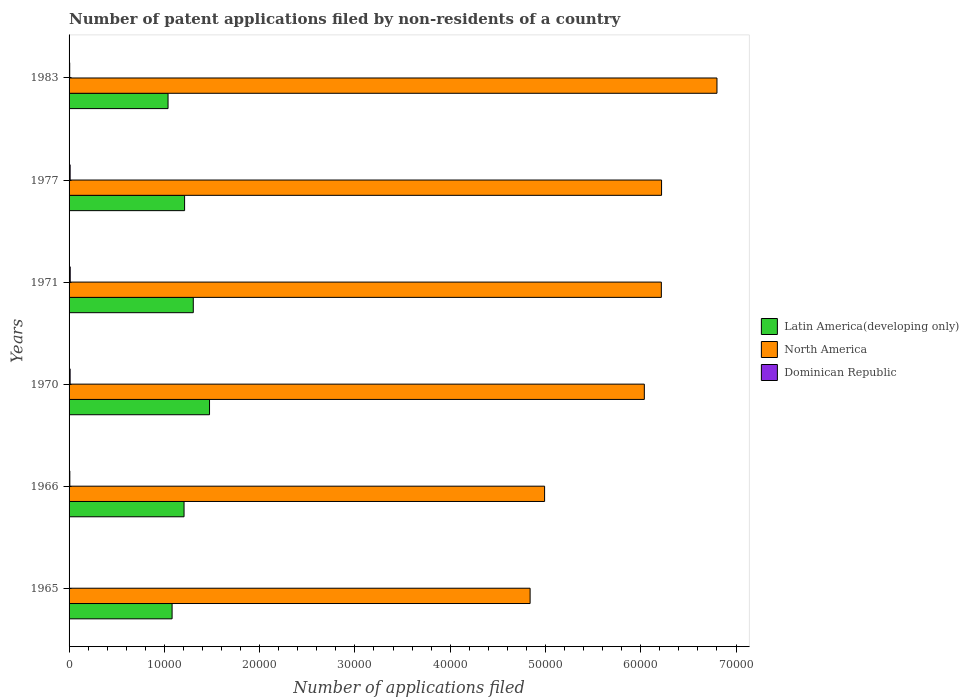How many bars are there on the 2nd tick from the bottom?
Give a very brief answer. 3. What is the number of applications filed in Latin America(developing only) in 1966?
Give a very brief answer. 1.21e+04. Across all years, what is the maximum number of applications filed in Dominican Republic?
Your response must be concise. 120. Across all years, what is the minimum number of applications filed in Latin America(developing only)?
Your answer should be very brief. 1.04e+04. In which year was the number of applications filed in Latin America(developing only) maximum?
Keep it short and to the point. 1970. In which year was the number of applications filed in North America minimum?
Your answer should be very brief. 1965. What is the total number of applications filed in Dominican Republic in the graph?
Your answer should be compact. 503. What is the difference between the number of applications filed in Latin America(developing only) in 1965 and that in 1970?
Your answer should be very brief. -3930. What is the difference between the number of applications filed in North America in 1970 and the number of applications filed in Dominican Republic in 1983?
Your answer should be very brief. 6.03e+04. What is the average number of applications filed in Dominican Republic per year?
Provide a succinct answer. 83.83. In the year 1970, what is the difference between the number of applications filed in Latin America(developing only) and number of applications filed in Dominican Republic?
Your answer should be compact. 1.46e+04. What is the ratio of the number of applications filed in North America in 1970 to that in 1983?
Provide a short and direct response. 0.89. What is the difference between the highest and the second highest number of applications filed in Latin America(developing only)?
Provide a short and direct response. 1706. What is the difference between the highest and the lowest number of applications filed in North America?
Provide a short and direct response. 1.96e+04. In how many years, is the number of applications filed in North America greater than the average number of applications filed in North America taken over all years?
Make the answer very short. 4. What does the 3rd bar from the top in 1977 represents?
Provide a short and direct response. Latin America(developing only). What does the 3rd bar from the bottom in 1966 represents?
Your response must be concise. Dominican Republic. Is it the case that in every year, the sum of the number of applications filed in Dominican Republic and number of applications filed in North America is greater than the number of applications filed in Latin America(developing only)?
Keep it short and to the point. Yes. How many bars are there?
Make the answer very short. 18. Are all the bars in the graph horizontal?
Offer a terse response. Yes. How many years are there in the graph?
Make the answer very short. 6. What is the difference between two consecutive major ticks on the X-axis?
Make the answer very short. 10000. Does the graph contain grids?
Give a very brief answer. No. How many legend labels are there?
Your answer should be very brief. 3. How are the legend labels stacked?
Your answer should be very brief. Vertical. What is the title of the graph?
Provide a short and direct response. Number of patent applications filed by non-residents of a country. What is the label or title of the X-axis?
Provide a succinct answer. Number of applications filed. What is the Number of applications filed in Latin America(developing only) in 1965?
Offer a terse response. 1.08e+04. What is the Number of applications filed of North America in 1965?
Give a very brief answer. 4.84e+04. What is the Number of applications filed in Dominican Republic in 1965?
Offer a very short reply. 15. What is the Number of applications filed in Latin America(developing only) in 1966?
Provide a short and direct response. 1.21e+04. What is the Number of applications filed in North America in 1966?
Offer a terse response. 4.99e+04. What is the Number of applications filed of Dominican Republic in 1966?
Provide a short and direct response. 80. What is the Number of applications filed of Latin America(developing only) in 1970?
Your response must be concise. 1.47e+04. What is the Number of applications filed in North America in 1970?
Ensure brevity in your answer.  6.04e+04. What is the Number of applications filed in Dominican Republic in 1970?
Provide a succinct answer. 110. What is the Number of applications filed of Latin America(developing only) in 1971?
Your answer should be very brief. 1.30e+04. What is the Number of applications filed of North America in 1971?
Ensure brevity in your answer.  6.22e+04. What is the Number of applications filed in Dominican Republic in 1971?
Give a very brief answer. 120. What is the Number of applications filed of Latin America(developing only) in 1977?
Your answer should be compact. 1.21e+04. What is the Number of applications filed of North America in 1977?
Make the answer very short. 6.22e+04. What is the Number of applications filed of Dominican Republic in 1977?
Make the answer very short. 112. What is the Number of applications filed of Latin America(developing only) in 1983?
Your answer should be compact. 1.04e+04. What is the Number of applications filed of North America in 1983?
Offer a very short reply. 6.80e+04. What is the Number of applications filed of Dominican Republic in 1983?
Make the answer very short. 66. Across all years, what is the maximum Number of applications filed of Latin America(developing only)?
Offer a terse response. 1.47e+04. Across all years, what is the maximum Number of applications filed of North America?
Your answer should be compact. 6.80e+04. Across all years, what is the maximum Number of applications filed in Dominican Republic?
Offer a very short reply. 120. Across all years, what is the minimum Number of applications filed in Latin America(developing only)?
Your response must be concise. 1.04e+04. Across all years, what is the minimum Number of applications filed of North America?
Provide a succinct answer. 4.84e+04. Across all years, what is the minimum Number of applications filed in Dominican Republic?
Ensure brevity in your answer.  15. What is the total Number of applications filed of Latin America(developing only) in the graph?
Your answer should be very brief. 7.32e+04. What is the total Number of applications filed of North America in the graph?
Your answer should be compact. 3.51e+05. What is the total Number of applications filed of Dominican Republic in the graph?
Your answer should be very brief. 503. What is the difference between the Number of applications filed of Latin America(developing only) in 1965 and that in 1966?
Offer a very short reply. -1254. What is the difference between the Number of applications filed of North America in 1965 and that in 1966?
Offer a very short reply. -1520. What is the difference between the Number of applications filed of Dominican Republic in 1965 and that in 1966?
Provide a short and direct response. -65. What is the difference between the Number of applications filed in Latin America(developing only) in 1965 and that in 1970?
Make the answer very short. -3930. What is the difference between the Number of applications filed of North America in 1965 and that in 1970?
Your answer should be very brief. -1.20e+04. What is the difference between the Number of applications filed of Dominican Republic in 1965 and that in 1970?
Your answer should be compact. -95. What is the difference between the Number of applications filed in Latin America(developing only) in 1965 and that in 1971?
Give a very brief answer. -2224. What is the difference between the Number of applications filed in North America in 1965 and that in 1971?
Offer a terse response. -1.38e+04. What is the difference between the Number of applications filed of Dominican Republic in 1965 and that in 1971?
Make the answer very short. -105. What is the difference between the Number of applications filed in Latin America(developing only) in 1965 and that in 1977?
Give a very brief answer. -1312. What is the difference between the Number of applications filed in North America in 1965 and that in 1977?
Offer a very short reply. -1.38e+04. What is the difference between the Number of applications filed of Dominican Republic in 1965 and that in 1977?
Give a very brief answer. -97. What is the difference between the Number of applications filed of Latin America(developing only) in 1965 and that in 1983?
Make the answer very short. 425. What is the difference between the Number of applications filed of North America in 1965 and that in 1983?
Provide a short and direct response. -1.96e+04. What is the difference between the Number of applications filed of Dominican Republic in 1965 and that in 1983?
Make the answer very short. -51. What is the difference between the Number of applications filed of Latin America(developing only) in 1966 and that in 1970?
Provide a succinct answer. -2676. What is the difference between the Number of applications filed of North America in 1966 and that in 1970?
Make the answer very short. -1.05e+04. What is the difference between the Number of applications filed in Latin America(developing only) in 1966 and that in 1971?
Provide a short and direct response. -970. What is the difference between the Number of applications filed in North America in 1966 and that in 1971?
Provide a short and direct response. -1.23e+04. What is the difference between the Number of applications filed of Latin America(developing only) in 1966 and that in 1977?
Provide a succinct answer. -58. What is the difference between the Number of applications filed of North America in 1966 and that in 1977?
Provide a succinct answer. -1.23e+04. What is the difference between the Number of applications filed of Dominican Republic in 1966 and that in 1977?
Your answer should be compact. -32. What is the difference between the Number of applications filed in Latin America(developing only) in 1966 and that in 1983?
Ensure brevity in your answer.  1679. What is the difference between the Number of applications filed of North America in 1966 and that in 1983?
Your response must be concise. -1.81e+04. What is the difference between the Number of applications filed in Latin America(developing only) in 1970 and that in 1971?
Provide a succinct answer. 1706. What is the difference between the Number of applications filed in North America in 1970 and that in 1971?
Offer a very short reply. -1786. What is the difference between the Number of applications filed of Dominican Republic in 1970 and that in 1971?
Offer a terse response. -10. What is the difference between the Number of applications filed of Latin America(developing only) in 1970 and that in 1977?
Your response must be concise. 2618. What is the difference between the Number of applications filed in North America in 1970 and that in 1977?
Give a very brief answer. -1808. What is the difference between the Number of applications filed of Latin America(developing only) in 1970 and that in 1983?
Ensure brevity in your answer.  4355. What is the difference between the Number of applications filed of North America in 1970 and that in 1983?
Ensure brevity in your answer.  -7624. What is the difference between the Number of applications filed in Latin America(developing only) in 1971 and that in 1977?
Your answer should be very brief. 912. What is the difference between the Number of applications filed in North America in 1971 and that in 1977?
Make the answer very short. -22. What is the difference between the Number of applications filed in Dominican Republic in 1971 and that in 1977?
Give a very brief answer. 8. What is the difference between the Number of applications filed of Latin America(developing only) in 1971 and that in 1983?
Provide a succinct answer. 2649. What is the difference between the Number of applications filed in North America in 1971 and that in 1983?
Offer a very short reply. -5838. What is the difference between the Number of applications filed in Latin America(developing only) in 1977 and that in 1983?
Offer a very short reply. 1737. What is the difference between the Number of applications filed in North America in 1977 and that in 1983?
Ensure brevity in your answer.  -5816. What is the difference between the Number of applications filed of Dominican Republic in 1977 and that in 1983?
Provide a short and direct response. 46. What is the difference between the Number of applications filed in Latin America(developing only) in 1965 and the Number of applications filed in North America in 1966?
Provide a short and direct response. -3.91e+04. What is the difference between the Number of applications filed of Latin America(developing only) in 1965 and the Number of applications filed of Dominican Republic in 1966?
Make the answer very short. 1.07e+04. What is the difference between the Number of applications filed of North America in 1965 and the Number of applications filed of Dominican Republic in 1966?
Your answer should be very brief. 4.83e+04. What is the difference between the Number of applications filed in Latin America(developing only) in 1965 and the Number of applications filed in North America in 1970?
Your answer should be compact. -4.96e+04. What is the difference between the Number of applications filed of Latin America(developing only) in 1965 and the Number of applications filed of Dominican Republic in 1970?
Provide a short and direct response. 1.07e+04. What is the difference between the Number of applications filed of North America in 1965 and the Number of applications filed of Dominican Republic in 1970?
Offer a terse response. 4.83e+04. What is the difference between the Number of applications filed in Latin America(developing only) in 1965 and the Number of applications filed in North America in 1971?
Your answer should be compact. -5.14e+04. What is the difference between the Number of applications filed in Latin America(developing only) in 1965 and the Number of applications filed in Dominican Republic in 1971?
Your response must be concise. 1.07e+04. What is the difference between the Number of applications filed of North America in 1965 and the Number of applications filed of Dominican Republic in 1971?
Give a very brief answer. 4.83e+04. What is the difference between the Number of applications filed of Latin America(developing only) in 1965 and the Number of applications filed of North America in 1977?
Make the answer very short. -5.14e+04. What is the difference between the Number of applications filed in Latin America(developing only) in 1965 and the Number of applications filed in Dominican Republic in 1977?
Your response must be concise. 1.07e+04. What is the difference between the Number of applications filed in North America in 1965 and the Number of applications filed in Dominican Republic in 1977?
Make the answer very short. 4.83e+04. What is the difference between the Number of applications filed of Latin America(developing only) in 1965 and the Number of applications filed of North America in 1983?
Give a very brief answer. -5.72e+04. What is the difference between the Number of applications filed in Latin America(developing only) in 1965 and the Number of applications filed in Dominican Republic in 1983?
Give a very brief answer. 1.07e+04. What is the difference between the Number of applications filed in North America in 1965 and the Number of applications filed in Dominican Republic in 1983?
Offer a very short reply. 4.83e+04. What is the difference between the Number of applications filed of Latin America(developing only) in 1966 and the Number of applications filed of North America in 1970?
Your answer should be very brief. -4.83e+04. What is the difference between the Number of applications filed in Latin America(developing only) in 1966 and the Number of applications filed in Dominican Republic in 1970?
Provide a succinct answer. 1.20e+04. What is the difference between the Number of applications filed in North America in 1966 and the Number of applications filed in Dominican Republic in 1970?
Ensure brevity in your answer.  4.98e+04. What is the difference between the Number of applications filed in Latin America(developing only) in 1966 and the Number of applications filed in North America in 1971?
Keep it short and to the point. -5.01e+04. What is the difference between the Number of applications filed in Latin America(developing only) in 1966 and the Number of applications filed in Dominican Republic in 1971?
Your answer should be very brief. 1.19e+04. What is the difference between the Number of applications filed in North America in 1966 and the Number of applications filed in Dominican Republic in 1971?
Offer a terse response. 4.98e+04. What is the difference between the Number of applications filed of Latin America(developing only) in 1966 and the Number of applications filed of North America in 1977?
Provide a short and direct response. -5.01e+04. What is the difference between the Number of applications filed of Latin America(developing only) in 1966 and the Number of applications filed of Dominican Republic in 1977?
Keep it short and to the point. 1.20e+04. What is the difference between the Number of applications filed of North America in 1966 and the Number of applications filed of Dominican Republic in 1977?
Make the answer very short. 4.98e+04. What is the difference between the Number of applications filed in Latin America(developing only) in 1966 and the Number of applications filed in North America in 1983?
Offer a very short reply. -5.59e+04. What is the difference between the Number of applications filed of Latin America(developing only) in 1966 and the Number of applications filed of Dominican Republic in 1983?
Ensure brevity in your answer.  1.20e+04. What is the difference between the Number of applications filed of North America in 1966 and the Number of applications filed of Dominican Republic in 1983?
Your response must be concise. 4.98e+04. What is the difference between the Number of applications filed of Latin America(developing only) in 1970 and the Number of applications filed of North America in 1971?
Give a very brief answer. -4.74e+04. What is the difference between the Number of applications filed of Latin America(developing only) in 1970 and the Number of applications filed of Dominican Republic in 1971?
Give a very brief answer. 1.46e+04. What is the difference between the Number of applications filed in North America in 1970 and the Number of applications filed in Dominican Republic in 1971?
Ensure brevity in your answer.  6.03e+04. What is the difference between the Number of applications filed of Latin America(developing only) in 1970 and the Number of applications filed of North America in 1977?
Ensure brevity in your answer.  -4.74e+04. What is the difference between the Number of applications filed in Latin America(developing only) in 1970 and the Number of applications filed in Dominican Republic in 1977?
Your response must be concise. 1.46e+04. What is the difference between the Number of applications filed in North America in 1970 and the Number of applications filed in Dominican Republic in 1977?
Offer a terse response. 6.03e+04. What is the difference between the Number of applications filed of Latin America(developing only) in 1970 and the Number of applications filed of North America in 1983?
Your answer should be compact. -5.33e+04. What is the difference between the Number of applications filed in Latin America(developing only) in 1970 and the Number of applications filed in Dominican Republic in 1983?
Make the answer very short. 1.47e+04. What is the difference between the Number of applications filed in North America in 1970 and the Number of applications filed in Dominican Republic in 1983?
Ensure brevity in your answer.  6.03e+04. What is the difference between the Number of applications filed of Latin America(developing only) in 1971 and the Number of applications filed of North America in 1977?
Your response must be concise. -4.91e+04. What is the difference between the Number of applications filed in Latin America(developing only) in 1971 and the Number of applications filed in Dominican Republic in 1977?
Give a very brief answer. 1.29e+04. What is the difference between the Number of applications filed in North America in 1971 and the Number of applications filed in Dominican Republic in 1977?
Offer a terse response. 6.21e+04. What is the difference between the Number of applications filed in Latin America(developing only) in 1971 and the Number of applications filed in North America in 1983?
Give a very brief answer. -5.50e+04. What is the difference between the Number of applications filed in Latin America(developing only) in 1971 and the Number of applications filed in Dominican Republic in 1983?
Your answer should be compact. 1.30e+04. What is the difference between the Number of applications filed in North America in 1971 and the Number of applications filed in Dominican Republic in 1983?
Ensure brevity in your answer.  6.21e+04. What is the difference between the Number of applications filed of Latin America(developing only) in 1977 and the Number of applications filed of North America in 1983?
Ensure brevity in your answer.  -5.59e+04. What is the difference between the Number of applications filed of Latin America(developing only) in 1977 and the Number of applications filed of Dominican Republic in 1983?
Offer a very short reply. 1.21e+04. What is the difference between the Number of applications filed of North America in 1977 and the Number of applications filed of Dominican Republic in 1983?
Keep it short and to the point. 6.21e+04. What is the average Number of applications filed of Latin America(developing only) per year?
Offer a terse response. 1.22e+04. What is the average Number of applications filed in North America per year?
Keep it short and to the point. 5.85e+04. What is the average Number of applications filed of Dominican Republic per year?
Provide a succinct answer. 83.83. In the year 1965, what is the difference between the Number of applications filed of Latin America(developing only) and Number of applications filed of North America?
Your answer should be compact. -3.76e+04. In the year 1965, what is the difference between the Number of applications filed of Latin America(developing only) and Number of applications filed of Dominican Republic?
Your answer should be very brief. 1.08e+04. In the year 1965, what is the difference between the Number of applications filed in North America and Number of applications filed in Dominican Republic?
Provide a short and direct response. 4.84e+04. In the year 1966, what is the difference between the Number of applications filed in Latin America(developing only) and Number of applications filed in North America?
Your answer should be very brief. -3.78e+04. In the year 1966, what is the difference between the Number of applications filed in Latin America(developing only) and Number of applications filed in Dominican Republic?
Provide a short and direct response. 1.20e+04. In the year 1966, what is the difference between the Number of applications filed of North America and Number of applications filed of Dominican Republic?
Provide a succinct answer. 4.98e+04. In the year 1970, what is the difference between the Number of applications filed of Latin America(developing only) and Number of applications filed of North America?
Give a very brief answer. -4.56e+04. In the year 1970, what is the difference between the Number of applications filed in Latin America(developing only) and Number of applications filed in Dominican Republic?
Make the answer very short. 1.46e+04. In the year 1970, what is the difference between the Number of applications filed of North America and Number of applications filed of Dominican Republic?
Offer a very short reply. 6.03e+04. In the year 1971, what is the difference between the Number of applications filed in Latin America(developing only) and Number of applications filed in North America?
Offer a terse response. -4.91e+04. In the year 1971, what is the difference between the Number of applications filed in Latin America(developing only) and Number of applications filed in Dominican Republic?
Give a very brief answer. 1.29e+04. In the year 1971, what is the difference between the Number of applications filed in North America and Number of applications filed in Dominican Republic?
Make the answer very short. 6.20e+04. In the year 1977, what is the difference between the Number of applications filed in Latin America(developing only) and Number of applications filed in North America?
Offer a terse response. -5.01e+04. In the year 1977, what is the difference between the Number of applications filed of Latin America(developing only) and Number of applications filed of Dominican Republic?
Make the answer very short. 1.20e+04. In the year 1977, what is the difference between the Number of applications filed of North America and Number of applications filed of Dominican Republic?
Offer a terse response. 6.21e+04. In the year 1983, what is the difference between the Number of applications filed of Latin America(developing only) and Number of applications filed of North America?
Your answer should be compact. -5.76e+04. In the year 1983, what is the difference between the Number of applications filed in Latin America(developing only) and Number of applications filed in Dominican Republic?
Give a very brief answer. 1.03e+04. In the year 1983, what is the difference between the Number of applications filed of North America and Number of applications filed of Dominican Republic?
Your answer should be compact. 6.79e+04. What is the ratio of the Number of applications filed of Latin America(developing only) in 1965 to that in 1966?
Provide a succinct answer. 0.9. What is the ratio of the Number of applications filed of North America in 1965 to that in 1966?
Keep it short and to the point. 0.97. What is the ratio of the Number of applications filed of Dominican Republic in 1965 to that in 1966?
Provide a short and direct response. 0.19. What is the ratio of the Number of applications filed in Latin America(developing only) in 1965 to that in 1970?
Offer a very short reply. 0.73. What is the ratio of the Number of applications filed in North America in 1965 to that in 1970?
Make the answer very short. 0.8. What is the ratio of the Number of applications filed of Dominican Republic in 1965 to that in 1970?
Offer a very short reply. 0.14. What is the ratio of the Number of applications filed of Latin America(developing only) in 1965 to that in 1971?
Offer a very short reply. 0.83. What is the ratio of the Number of applications filed in North America in 1965 to that in 1971?
Give a very brief answer. 0.78. What is the ratio of the Number of applications filed in Latin America(developing only) in 1965 to that in 1977?
Ensure brevity in your answer.  0.89. What is the ratio of the Number of applications filed of North America in 1965 to that in 1977?
Your answer should be compact. 0.78. What is the ratio of the Number of applications filed in Dominican Republic in 1965 to that in 1977?
Ensure brevity in your answer.  0.13. What is the ratio of the Number of applications filed of Latin America(developing only) in 1965 to that in 1983?
Your answer should be very brief. 1.04. What is the ratio of the Number of applications filed in North America in 1965 to that in 1983?
Your answer should be very brief. 0.71. What is the ratio of the Number of applications filed of Dominican Republic in 1965 to that in 1983?
Ensure brevity in your answer.  0.23. What is the ratio of the Number of applications filed of Latin America(developing only) in 1966 to that in 1970?
Offer a terse response. 0.82. What is the ratio of the Number of applications filed of North America in 1966 to that in 1970?
Provide a short and direct response. 0.83. What is the ratio of the Number of applications filed in Dominican Republic in 1966 to that in 1970?
Offer a terse response. 0.73. What is the ratio of the Number of applications filed of Latin America(developing only) in 1966 to that in 1971?
Ensure brevity in your answer.  0.93. What is the ratio of the Number of applications filed of North America in 1966 to that in 1971?
Offer a terse response. 0.8. What is the ratio of the Number of applications filed in North America in 1966 to that in 1977?
Your answer should be very brief. 0.8. What is the ratio of the Number of applications filed in Latin America(developing only) in 1966 to that in 1983?
Keep it short and to the point. 1.16. What is the ratio of the Number of applications filed of North America in 1966 to that in 1983?
Your answer should be very brief. 0.73. What is the ratio of the Number of applications filed in Dominican Republic in 1966 to that in 1983?
Provide a short and direct response. 1.21. What is the ratio of the Number of applications filed of Latin America(developing only) in 1970 to that in 1971?
Offer a terse response. 1.13. What is the ratio of the Number of applications filed in North America in 1970 to that in 1971?
Provide a short and direct response. 0.97. What is the ratio of the Number of applications filed in Dominican Republic in 1970 to that in 1971?
Make the answer very short. 0.92. What is the ratio of the Number of applications filed in Latin America(developing only) in 1970 to that in 1977?
Your answer should be very brief. 1.22. What is the ratio of the Number of applications filed of North America in 1970 to that in 1977?
Ensure brevity in your answer.  0.97. What is the ratio of the Number of applications filed of Dominican Republic in 1970 to that in 1977?
Give a very brief answer. 0.98. What is the ratio of the Number of applications filed of Latin America(developing only) in 1970 to that in 1983?
Ensure brevity in your answer.  1.42. What is the ratio of the Number of applications filed in North America in 1970 to that in 1983?
Provide a short and direct response. 0.89. What is the ratio of the Number of applications filed in Latin America(developing only) in 1971 to that in 1977?
Provide a succinct answer. 1.08. What is the ratio of the Number of applications filed in North America in 1971 to that in 1977?
Provide a short and direct response. 1. What is the ratio of the Number of applications filed in Dominican Republic in 1971 to that in 1977?
Make the answer very short. 1.07. What is the ratio of the Number of applications filed in Latin America(developing only) in 1971 to that in 1983?
Offer a terse response. 1.25. What is the ratio of the Number of applications filed of North America in 1971 to that in 1983?
Make the answer very short. 0.91. What is the ratio of the Number of applications filed in Dominican Republic in 1971 to that in 1983?
Offer a very short reply. 1.82. What is the ratio of the Number of applications filed in Latin America(developing only) in 1977 to that in 1983?
Keep it short and to the point. 1.17. What is the ratio of the Number of applications filed in North America in 1977 to that in 1983?
Ensure brevity in your answer.  0.91. What is the ratio of the Number of applications filed in Dominican Republic in 1977 to that in 1983?
Your response must be concise. 1.7. What is the difference between the highest and the second highest Number of applications filed of Latin America(developing only)?
Offer a terse response. 1706. What is the difference between the highest and the second highest Number of applications filed of North America?
Make the answer very short. 5816. What is the difference between the highest and the lowest Number of applications filed in Latin America(developing only)?
Keep it short and to the point. 4355. What is the difference between the highest and the lowest Number of applications filed of North America?
Your response must be concise. 1.96e+04. What is the difference between the highest and the lowest Number of applications filed in Dominican Republic?
Offer a terse response. 105. 